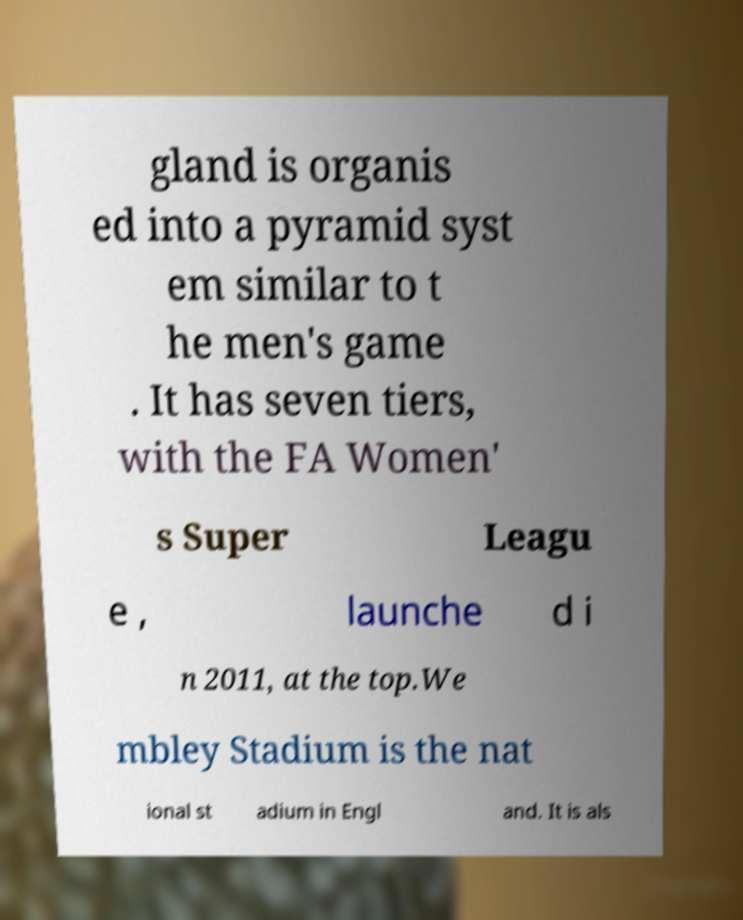Could you assist in decoding the text presented in this image and type it out clearly? gland is organis ed into a pyramid syst em similar to t he men's game . It has seven tiers, with the FA Women' s Super Leagu e , launche d i n 2011, at the top.We mbley Stadium is the nat ional st adium in Engl and. It is als 